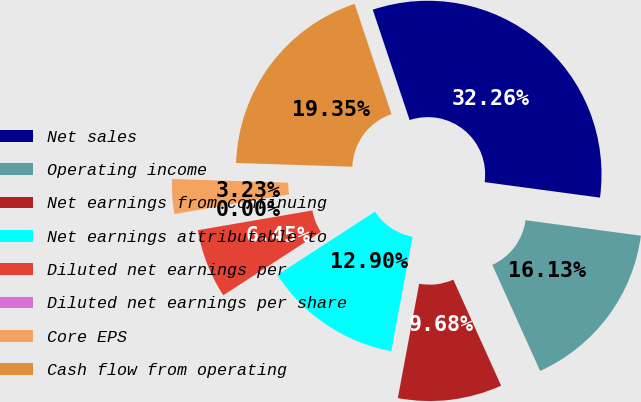Convert chart to OTSL. <chart><loc_0><loc_0><loc_500><loc_500><pie_chart><fcel>Net sales<fcel>Operating income<fcel>Net earnings from continuing<fcel>Net earnings attributable to<fcel>Diluted net earnings per<fcel>Diluted net earnings per share<fcel>Core EPS<fcel>Cash flow from operating<nl><fcel>32.26%<fcel>16.13%<fcel>9.68%<fcel>12.9%<fcel>6.45%<fcel>0.0%<fcel>3.23%<fcel>19.35%<nl></chart> 